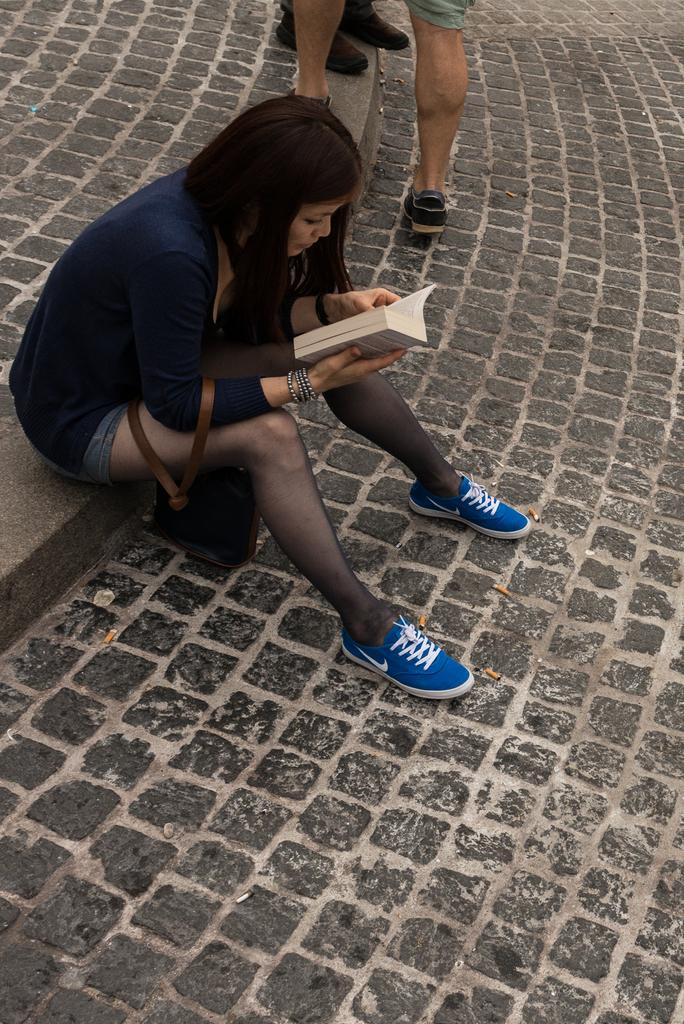What is the person in the image doing? The person in the image is holding a book. What is the person wearing in the image? The person is wearing a blue top and blue shoes. Can you describe the background of the image? There are people on the floor in the background of the image. How many tomatoes can be seen on the person's head in the image? There are no tomatoes present on the person's head in the image. Can you describe the person pulling a key from their pocket in the image? There is: There is no person pulling a key from their pocket in the image. 